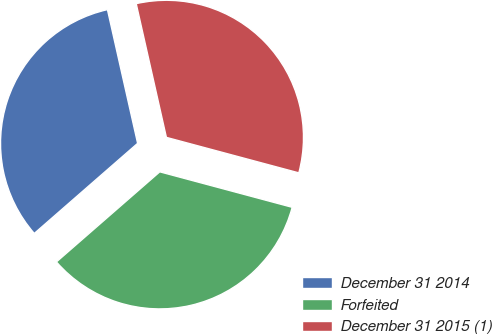Convert chart to OTSL. <chart><loc_0><loc_0><loc_500><loc_500><pie_chart><fcel>December 31 2014<fcel>Forfeited<fcel>December 31 2015 (1)<nl><fcel>32.88%<fcel>34.42%<fcel>32.7%<nl></chart> 